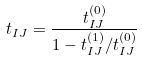Convert formula to latex. <formula><loc_0><loc_0><loc_500><loc_500>t _ { I J } = \frac { t _ { I J } ^ { ( 0 ) } } { 1 - t _ { I J } ^ { ( 1 ) } / t _ { I J } ^ { ( 0 ) } }</formula> 